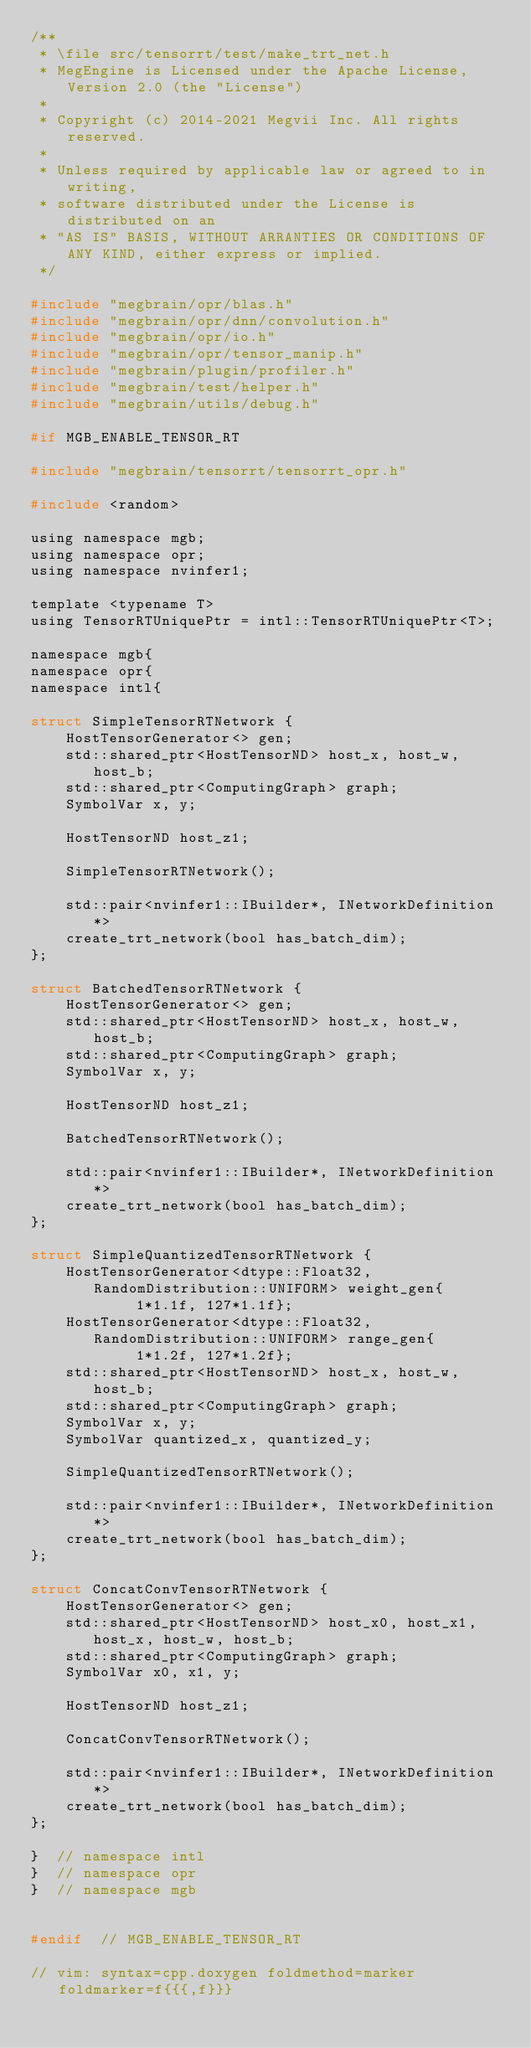Convert code to text. <code><loc_0><loc_0><loc_500><loc_500><_C_>/**
 * \file src/tensorrt/test/make_trt_net.h
 * MegEngine is Licensed under the Apache License, Version 2.0 (the "License")
 *
 * Copyright (c) 2014-2021 Megvii Inc. All rights reserved.
 *
 * Unless required by applicable law or agreed to in writing,
 * software distributed under the License is distributed on an
 * "AS IS" BASIS, WITHOUT ARRANTIES OR CONDITIONS OF ANY KIND, either express or implied.
 */

#include "megbrain/opr/blas.h"
#include "megbrain/opr/dnn/convolution.h"
#include "megbrain/opr/io.h"
#include "megbrain/opr/tensor_manip.h"
#include "megbrain/plugin/profiler.h"
#include "megbrain/test/helper.h"
#include "megbrain/utils/debug.h"

#if MGB_ENABLE_TENSOR_RT

#include "megbrain/tensorrt/tensorrt_opr.h"

#include <random>

using namespace mgb;
using namespace opr;
using namespace nvinfer1;

template <typename T>
using TensorRTUniquePtr = intl::TensorRTUniquePtr<T>;

namespace mgb{
namespace opr{
namespace intl{

struct SimpleTensorRTNetwork {
    HostTensorGenerator<> gen;
    std::shared_ptr<HostTensorND> host_x, host_w, host_b;
    std::shared_ptr<ComputingGraph> graph;
    SymbolVar x, y;

    HostTensorND host_z1;

    SimpleTensorRTNetwork();

    std::pair<nvinfer1::IBuilder*, INetworkDefinition*>
    create_trt_network(bool has_batch_dim);
};

struct BatchedTensorRTNetwork {
    HostTensorGenerator<> gen;
    std::shared_ptr<HostTensorND> host_x, host_w, host_b;
    std::shared_ptr<ComputingGraph> graph;
    SymbolVar x, y;

    HostTensorND host_z1;

    BatchedTensorRTNetwork();

    std::pair<nvinfer1::IBuilder*, INetworkDefinition*>
    create_trt_network(bool has_batch_dim);
};

struct SimpleQuantizedTensorRTNetwork {
    HostTensorGenerator<dtype::Float32, RandomDistribution::UNIFORM> weight_gen{
            1*1.1f, 127*1.1f};
    HostTensorGenerator<dtype::Float32, RandomDistribution::UNIFORM> range_gen{
            1*1.2f, 127*1.2f};
    std::shared_ptr<HostTensorND> host_x, host_w, host_b;
    std::shared_ptr<ComputingGraph> graph;
    SymbolVar x, y;
    SymbolVar quantized_x, quantized_y;

    SimpleQuantizedTensorRTNetwork();

    std::pair<nvinfer1::IBuilder*, INetworkDefinition*>
    create_trt_network(bool has_batch_dim);
};

struct ConcatConvTensorRTNetwork {
    HostTensorGenerator<> gen;
    std::shared_ptr<HostTensorND> host_x0, host_x1, host_x, host_w, host_b;
    std::shared_ptr<ComputingGraph> graph;
    SymbolVar x0, x1, y;

    HostTensorND host_z1;

    ConcatConvTensorRTNetwork();

    std::pair<nvinfer1::IBuilder*, INetworkDefinition*>
    create_trt_network(bool has_batch_dim);
};

}  // namespace intl
}  // namespace opr
}  // namespace mgb


#endif  // MGB_ENABLE_TENSOR_RT

// vim: syntax=cpp.doxygen foldmethod=marker foldmarker=f{{{,f}}}
</code> 